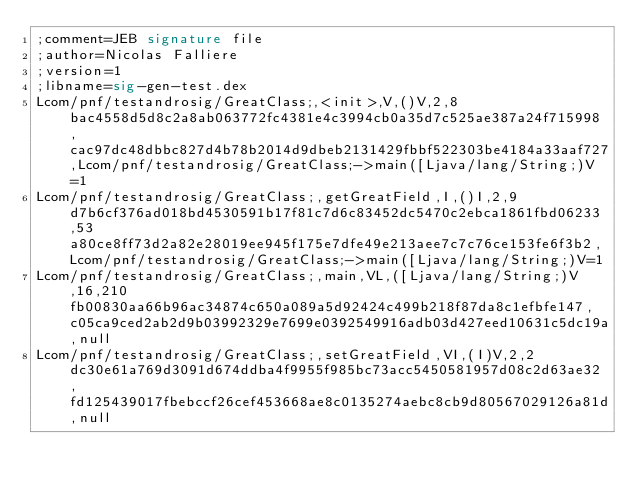<code> <loc_0><loc_0><loc_500><loc_500><_SML_>;comment=JEB signature file
;author=Nicolas Falliere
;version=1
;libname=sig-gen-test.dex
Lcom/pnf/testandrosig/GreatClass;,<init>,V,()V,2,8bac4558d5d8c2a8ab063772fc4381e4c3994cb0a35d7c525ae387a24f715998,cac97dc48dbbc827d4b78b2014d9dbeb2131429fbbf522303be4184a33aaf727,Lcom/pnf/testandrosig/GreatClass;->main([Ljava/lang/String;)V=1
Lcom/pnf/testandrosig/GreatClass;,getGreatField,I,()I,2,9d7b6cf376ad018bd4530591b17f81c7d6c83452dc5470c2ebca1861fbd06233,53a80ce8ff73d2a82e28019ee945f175e7dfe49e213aee7c7c76ce153fe6f3b2,Lcom/pnf/testandrosig/GreatClass;->main([Ljava/lang/String;)V=1
Lcom/pnf/testandrosig/GreatClass;,main,VL,([Ljava/lang/String;)V,16,210fb00830aa66b96ac34874c650a089a5d92424c499b218f87da8c1efbfe147,c05ca9ced2ab2d9b03992329e7699e0392549916adb03d427eed10631c5dc19a,null
Lcom/pnf/testandrosig/GreatClass;,setGreatField,VI,(I)V,2,2dc30e61a769d3091d674ddba4f9955f985bc73acc5450581957d08c2d63ae32,fd125439017fbebccf26cef453668ae8c0135274aebc8cb9d80567029126a81d,null
</code> 